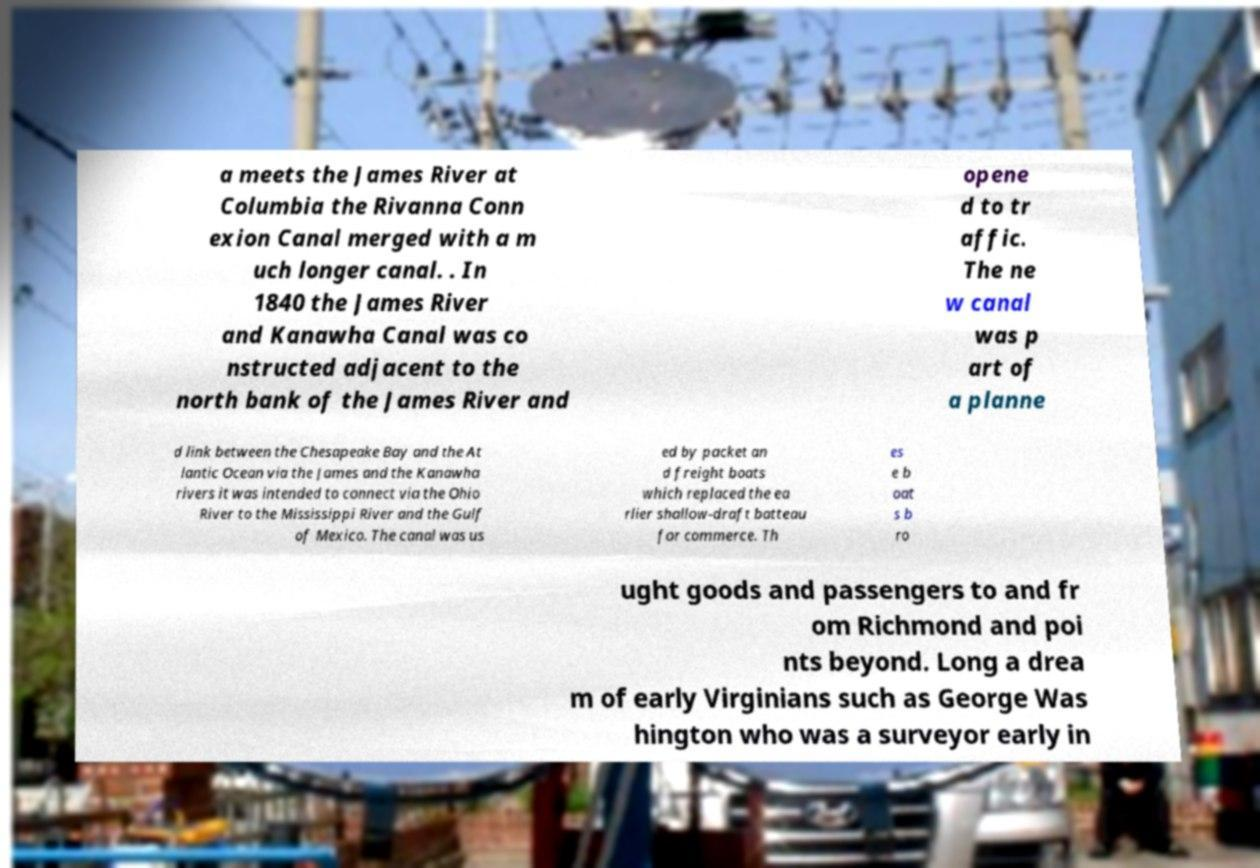Can you accurately transcribe the text from the provided image for me? a meets the James River at Columbia the Rivanna Conn exion Canal merged with a m uch longer canal. . In 1840 the James River and Kanawha Canal was co nstructed adjacent to the north bank of the James River and opene d to tr affic. The ne w canal was p art of a planne d link between the Chesapeake Bay and the At lantic Ocean via the James and the Kanawha rivers it was intended to connect via the Ohio River to the Mississippi River and the Gulf of Mexico. The canal was us ed by packet an d freight boats which replaced the ea rlier shallow-draft batteau for commerce. Th es e b oat s b ro ught goods and passengers to and fr om Richmond and poi nts beyond. Long a drea m of early Virginians such as George Was hington who was a surveyor early in 